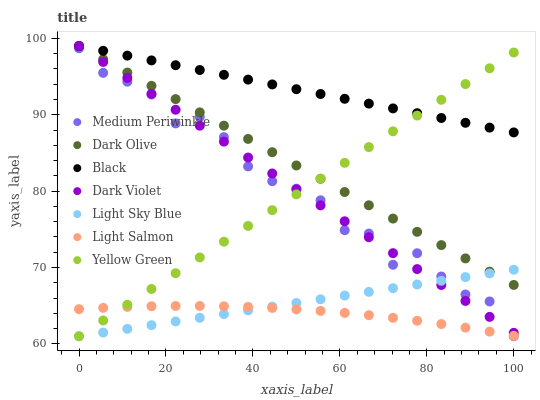Does Light Salmon have the minimum area under the curve?
Answer yes or no. Yes. Does Black have the maximum area under the curve?
Answer yes or no. Yes. Does Yellow Green have the minimum area under the curve?
Answer yes or no. No. Does Yellow Green have the maximum area under the curve?
Answer yes or no. No. Is Light Sky Blue the smoothest?
Answer yes or no. Yes. Is Medium Periwinkle the roughest?
Answer yes or no. Yes. Is Yellow Green the smoothest?
Answer yes or no. No. Is Yellow Green the roughest?
Answer yes or no. No. Does Yellow Green have the lowest value?
Answer yes or no. Yes. Does Dark Olive have the lowest value?
Answer yes or no. No. Does Black have the highest value?
Answer yes or no. Yes. Does Yellow Green have the highest value?
Answer yes or no. No. Is Light Salmon less than Dark Violet?
Answer yes or no. Yes. Is Dark Violet greater than Light Salmon?
Answer yes or no. Yes. Does Medium Periwinkle intersect Light Sky Blue?
Answer yes or no. Yes. Is Medium Periwinkle less than Light Sky Blue?
Answer yes or no. No. Is Medium Periwinkle greater than Light Sky Blue?
Answer yes or no. No. Does Light Salmon intersect Dark Violet?
Answer yes or no. No. 